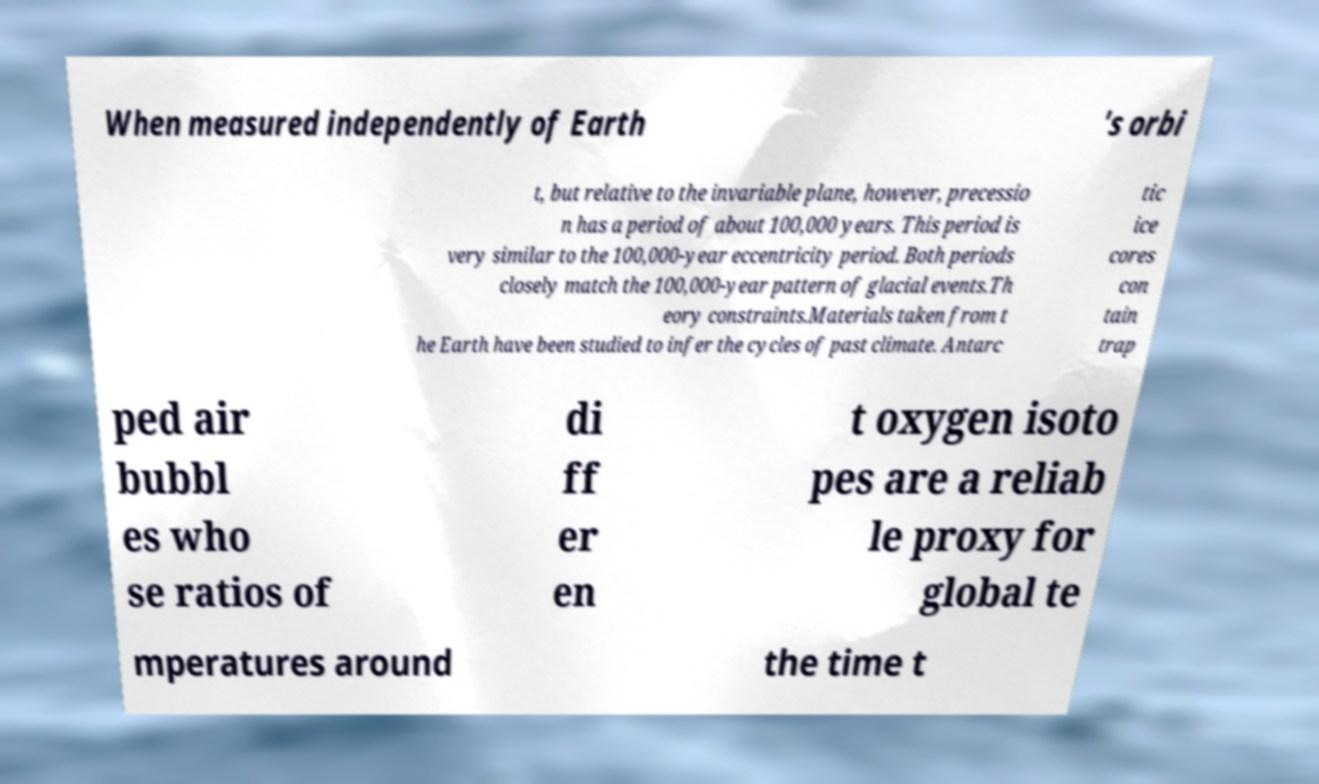Could you assist in decoding the text presented in this image and type it out clearly? When measured independently of Earth 's orbi t, but relative to the invariable plane, however, precessio n has a period of about 100,000 years. This period is very similar to the 100,000-year eccentricity period. Both periods closely match the 100,000-year pattern of glacial events.Th eory constraints.Materials taken from t he Earth have been studied to infer the cycles of past climate. Antarc tic ice cores con tain trap ped air bubbl es who se ratios of di ff er en t oxygen isoto pes are a reliab le proxy for global te mperatures around the time t 